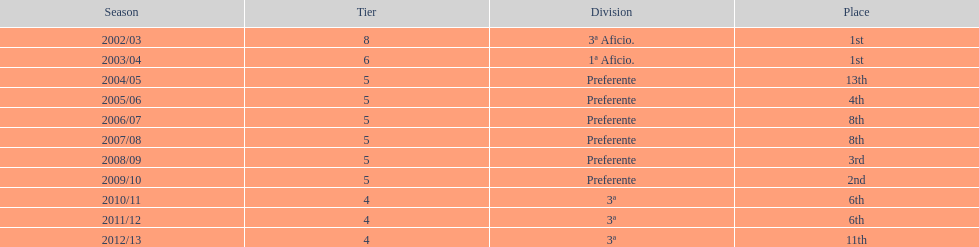What place was 1a aficio and 3a aficio? 1st. Can you give me this table as a dict? {'header': ['Season', 'Tier', 'Division', 'Place'], 'rows': [['2002/03', '8', '3ª Aficio.', '1st'], ['2003/04', '6', '1ª Aficio.', '1st'], ['2004/05', '5', 'Preferente', '13th'], ['2005/06', '5', 'Preferente', '4th'], ['2006/07', '5', 'Preferente', '8th'], ['2007/08', '5', 'Preferente', '8th'], ['2008/09', '5', 'Preferente', '3rd'], ['2009/10', '5', 'Preferente', '2nd'], ['2010/11', '4', '3ª', '6th'], ['2011/12', '4', '3ª', '6th'], ['2012/13', '4', '3ª', '11th']]} 